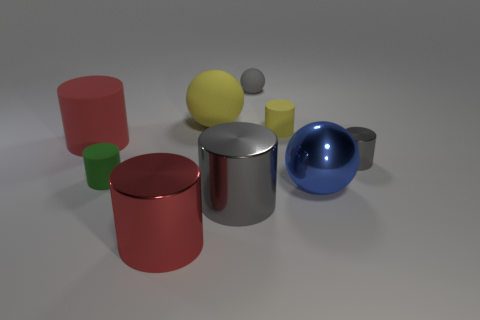The object that is to the left of the small rubber cylinder on the left side of the big red shiny object is made of what material?
Your answer should be compact. Rubber. There is a rubber thing that is right of the tiny gray ball; is its color the same as the large matte sphere?
Provide a short and direct response. Yes. How many other big objects have the same shape as the blue thing?
Make the answer very short. 1. There is a green thing that is the same material as the large yellow ball; what size is it?
Provide a short and direct response. Small. There is a metal cylinder that is to the right of the small gray thing that is to the left of the tiny gray cylinder; is there a cylinder in front of it?
Your answer should be compact. Yes. Does the red cylinder that is behind the red shiny cylinder have the same size as the large yellow rubber sphere?
Give a very brief answer. Yes. How many spheres are the same size as the yellow rubber cylinder?
Provide a short and direct response. 1. What is the size of the sphere that is the same color as the tiny metal thing?
Offer a very short reply. Small. Do the small sphere and the small metallic object have the same color?
Provide a short and direct response. Yes. The small green thing is what shape?
Ensure brevity in your answer.  Cylinder. 